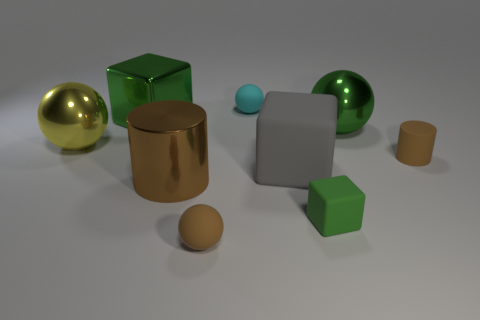Subtract all cylinders. How many objects are left? 7 Subtract all big brown shiny spheres. Subtract all big gray rubber objects. How many objects are left? 8 Add 6 gray rubber blocks. How many gray rubber blocks are left? 7 Add 9 tiny cylinders. How many tiny cylinders exist? 10 Subtract 0 purple balls. How many objects are left? 9 